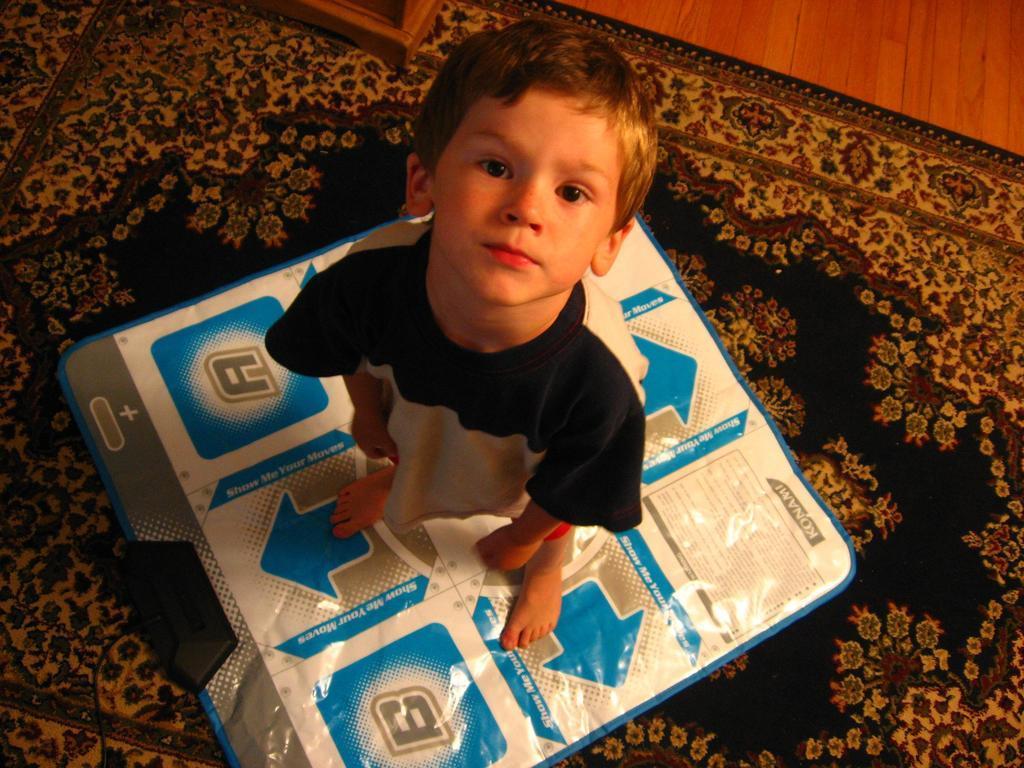Please provide a concise description of this image. In this image we can see a boy standing on the cover. At the bottom of the image there is carpet. 